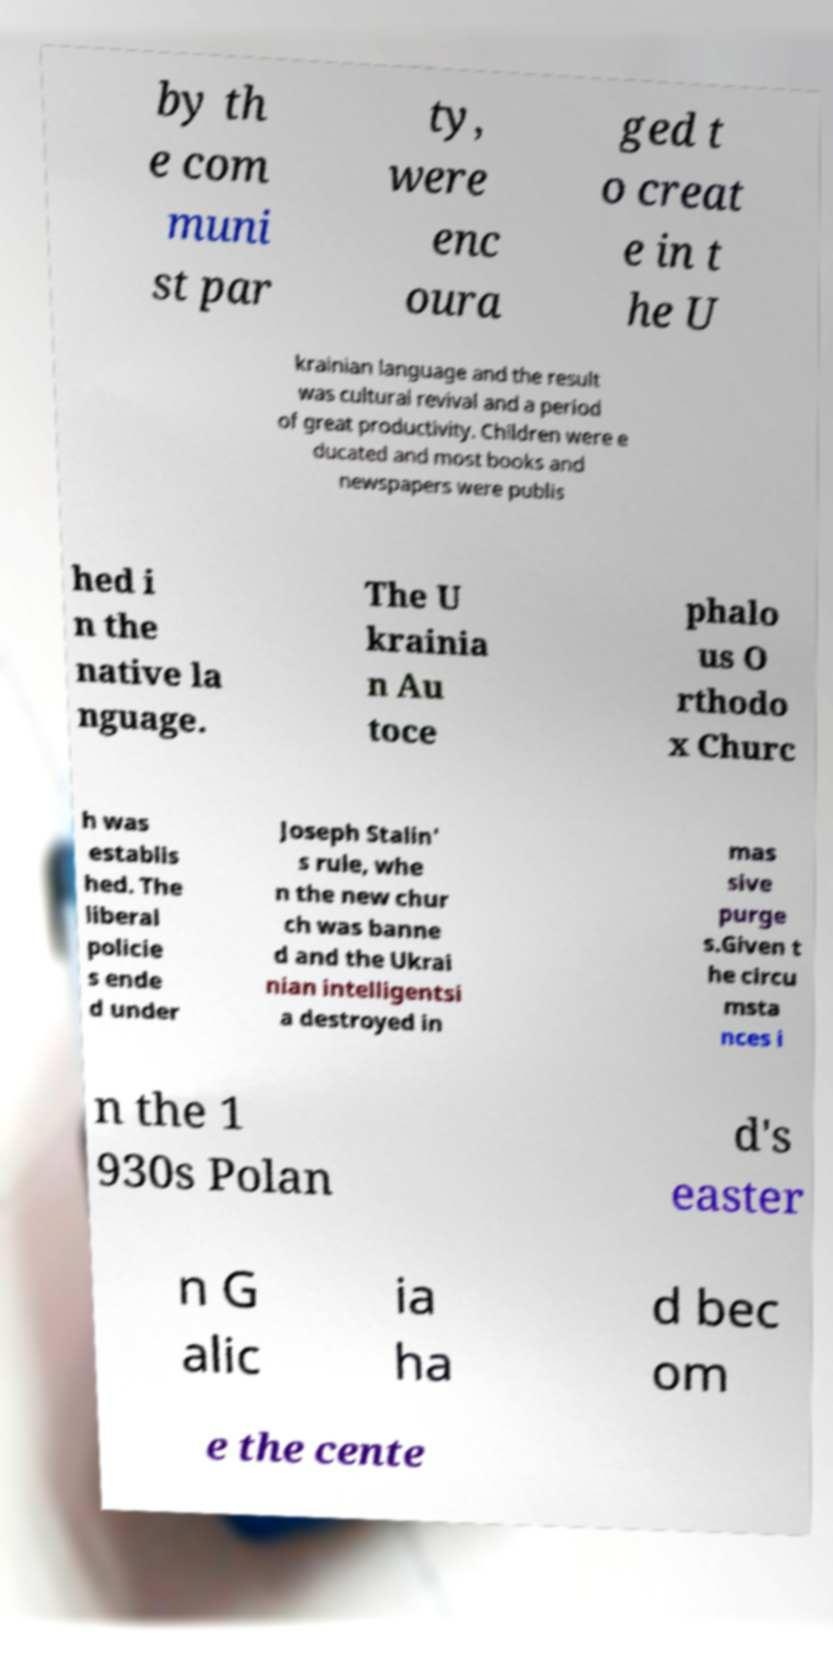Can you accurately transcribe the text from the provided image for me? by th e com muni st par ty, were enc oura ged t o creat e in t he U krainian language and the result was cultural revival and a period of great productivity. Children were e ducated and most books and newspapers were publis hed i n the native la nguage. The U krainia n Au toce phalo us O rthodo x Churc h was establis hed. The liberal policie s ende d under Joseph Stalin' s rule, whe n the new chur ch was banne d and the Ukrai nian intelligentsi a destroyed in mas sive purge s.Given t he circu msta nces i n the 1 930s Polan d's easter n G alic ia ha d bec om e the cente 